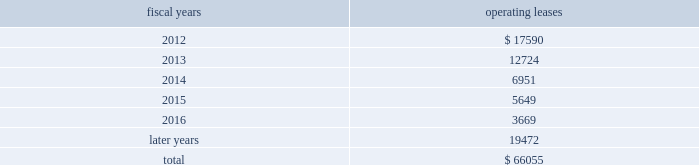The following is a schedule of future minimum rental payments required under long-term operating leases at october 29 , 2011 : fiscal years operating leases .
12 .
Commitments and contingencies from time to time in the ordinary course of the company 2019s business , various claims , charges and litigation are asserted or commenced against the company arising from , or related to , contractual matters , patents , trademarks , personal injury , environmental matters , product liability , insurance coverage and personnel and employment disputes .
As to such claims and litigation , the company can give no assurance that it will prevail .
The company does not believe that any current legal matters will have a material adverse effect on the company 2019s financial position , results of operations or cash flows .
13 .
Retirement plans the company and its subsidiaries have various savings and retirement plans covering substantially all employees .
The company maintains a defined contribution plan for the benefit of its eligible u.s .
Employees .
This plan provides for company contributions of up to 5% ( 5 % ) of each participant 2019s total eligible compensation .
In addition , the company contributes an amount equal to each participant 2019s pre-tax contribution , if any , up to a maximum of 3% ( 3 % ) of each participant 2019s total eligible compensation .
The total expense related to the defined contribution plan for u.s .
Employees was $ 21.9 million in fiscal 2011 , $ 20.5 million in fiscal 2010 and $ 21.5 million in fiscal 2009 .
The company also has various defined benefit pension and other retirement plans for certain non-u.s .
Employees that are consistent with local statutory requirements and practices .
The total expense related to the various defined benefit pension and other retirement plans for certain non-u.s .
Employees was $ 21.4 million in fiscal 2011 , $ 11.7 million in fiscal 2010 and $ 10.9 million in fiscal 2009 .
Non-u.s .
Plan disclosures the company 2019s funding policy for its foreign defined benefit pension plans is consistent with the local requirements of each country .
The plans 2019 assets consist primarily of u.s .
And non-u.s .
Equity securities , bonds , property and cash .
The benefit obligations and related assets under these plans have been measured at october 29 , 2011 and october 30 , 2010 .
Analog devices , inc .
Notes to consolidated financial statements 2014 ( continued ) .
What is the growth rate in the total expense related to the defined contribution plan for u.s.employees in 2011? 
Computations: ((21.9 - 20.5) / 20.5)
Answer: 0.06829. 